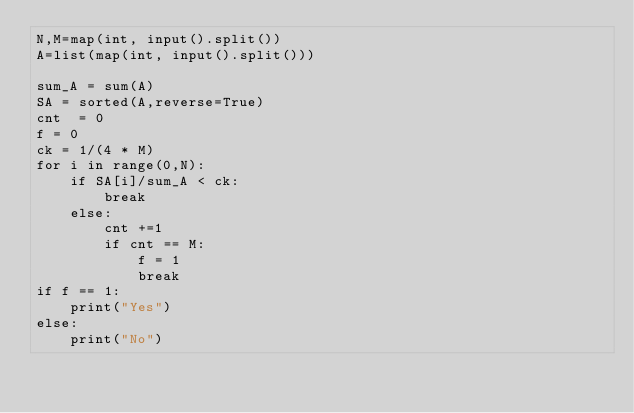Convert code to text. <code><loc_0><loc_0><loc_500><loc_500><_Python_>N,M=map(int, input().split())
A=list(map(int, input().split()))

sum_A = sum(A)
SA = sorted(A,reverse=True)
cnt  = 0
f = 0
ck = 1/(4 * M)
for i in range(0,N):
    if SA[i]/sum_A < ck:
        break
    else:
        cnt +=1
        if cnt == M:
            f = 1
            break
if f == 1:
    print("Yes")
else:
    print("No")</code> 